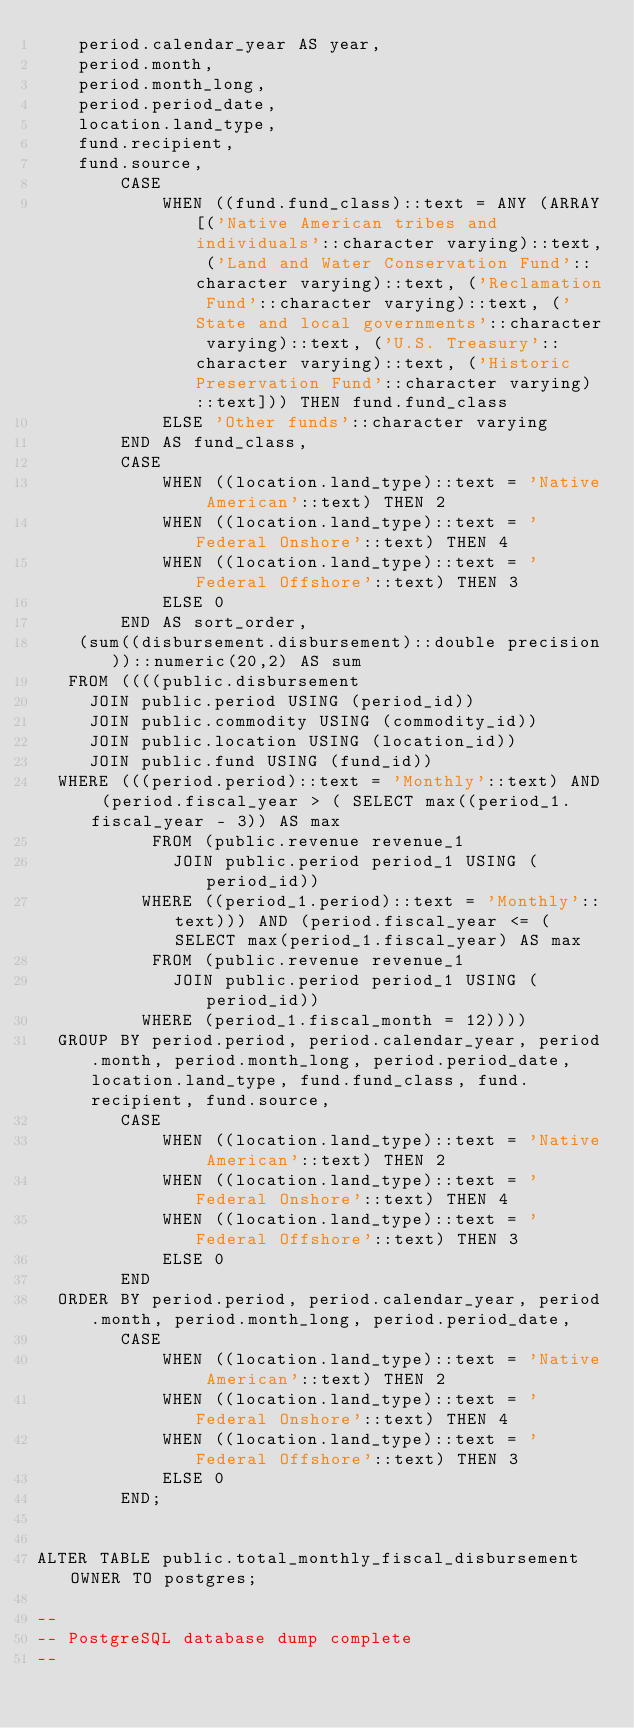<code> <loc_0><loc_0><loc_500><loc_500><_SQL_>    period.calendar_year AS year,
    period.month,
    period.month_long,
    period.period_date,
    location.land_type,
    fund.recipient,
    fund.source,
        CASE
            WHEN ((fund.fund_class)::text = ANY (ARRAY[('Native American tribes and individuals'::character varying)::text, ('Land and Water Conservation Fund'::character varying)::text, ('Reclamation Fund'::character varying)::text, ('State and local governments'::character varying)::text, ('U.S. Treasury'::character varying)::text, ('Historic Preservation Fund'::character varying)::text])) THEN fund.fund_class
            ELSE 'Other funds'::character varying
        END AS fund_class,
        CASE
            WHEN ((location.land_type)::text = 'Native American'::text) THEN 2
            WHEN ((location.land_type)::text = 'Federal Onshore'::text) THEN 4
            WHEN ((location.land_type)::text = 'Federal Offshore'::text) THEN 3
            ELSE 0
        END AS sort_order,
    (sum((disbursement.disbursement)::double precision))::numeric(20,2) AS sum
   FROM ((((public.disbursement
     JOIN public.period USING (period_id))
     JOIN public.commodity USING (commodity_id))
     JOIN public.location USING (location_id))
     JOIN public.fund USING (fund_id))
  WHERE (((period.period)::text = 'Monthly'::text) AND (period.fiscal_year > ( SELECT max((period_1.fiscal_year - 3)) AS max
           FROM (public.revenue revenue_1
             JOIN public.period period_1 USING (period_id))
          WHERE ((period_1.period)::text = 'Monthly'::text))) AND (period.fiscal_year <= ( SELECT max(period_1.fiscal_year) AS max
           FROM (public.revenue revenue_1
             JOIN public.period period_1 USING (period_id))
          WHERE (period_1.fiscal_month = 12))))
  GROUP BY period.period, period.calendar_year, period.month, period.month_long, period.period_date, location.land_type, fund.fund_class, fund.recipient, fund.source,
        CASE
            WHEN ((location.land_type)::text = 'Native American'::text) THEN 2
            WHEN ((location.land_type)::text = 'Federal Onshore'::text) THEN 4
            WHEN ((location.land_type)::text = 'Federal Offshore'::text) THEN 3
            ELSE 0
        END
  ORDER BY period.period, period.calendar_year, period.month, period.month_long, period.period_date,
        CASE
            WHEN ((location.land_type)::text = 'Native American'::text) THEN 2
            WHEN ((location.land_type)::text = 'Federal Onshore'::text) THEN 4
            WHEN ((location.land_type)::text = 'Federal Offshore'::text) THEN 3
            ELSE 0
        END;


ALTER TABLE public.total_monthly_fiscal_disbursement OWNER TO postgres;

--
-- PostgreSQL database dump complete
--

</code> 